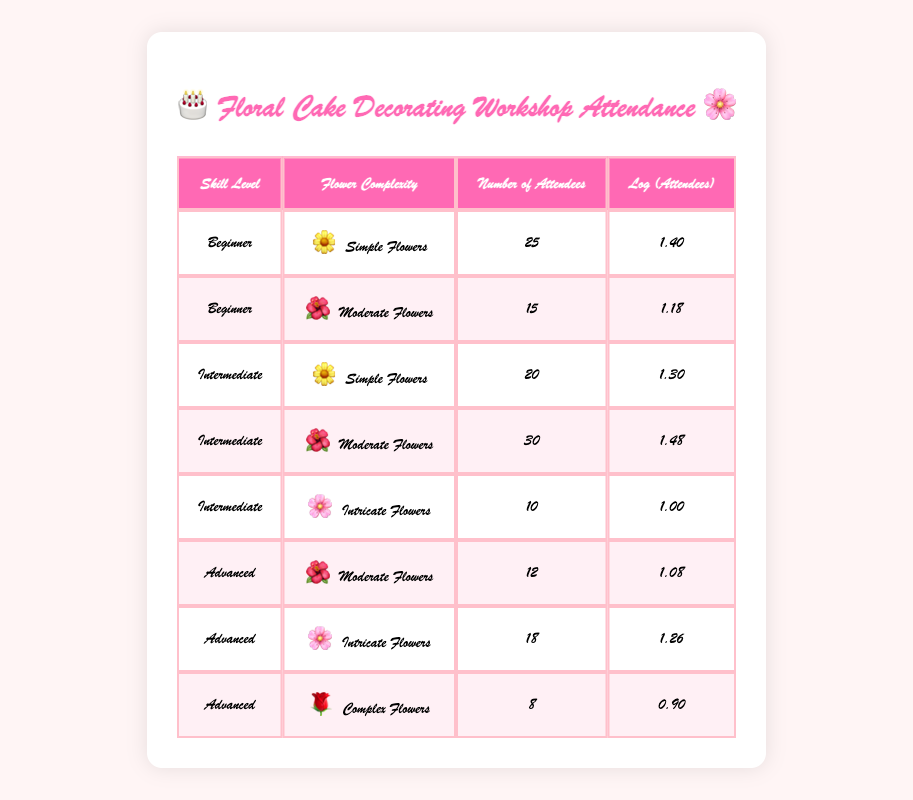What is the number of attendees for Intermediate skill level and Moderate Flowers? From the table, under the Intermediate skill level, the row for Moderate Flowers shows a number of attendees as 30.
Answer: 30 What is the logarithmic value for the number of attendees in Advanced skill level and Complex Flowers? In the table, the Advanced skill level for Complex Flowers has 8 attendees, and the logarithmic value for this is listed as 0.90.
Answer: 0.90 How many total attendees participated in Simple Flowers across all skill levels? To find the total for Simple Flowers, we look at the rows for each skill level: 25 (Beginner) + 20 (Intermediate) = 45. Therefore, the total attendees for Simple Flowers is 45.
Answer: 45 What is the average number of attendees for Advanced skill level sessions? For Advanced skill level: the number of attendees are 12 (Moderate) + 18 (Intricate) + 8 (Complex) = 38. There are 3 sessions, so the average is 38 / 3 = 12.67.
Answer: 12.67 Is the number of attendees for Beginner skill level and Moderate Flowers higher than for Intermediate skill level and Simple Flowers? The Beginner skill level for Moderate Flowers has 15 attendees, while Intermediate skill level for Simple Flowers has 20 attendees. Thus, 15 is not higher than 20, making the statement false.
Answer: No Which flower complexity category has the highest number of attendees for the Intermediate skill level? Within the Intermediate skill level, the number of attendees for each flower complexity is: 20 (Simple Flowers), 30 (Moderate Flowers), and 10 (Intricate Flowers). The highest is 30 attendees for Moderate Flowers.
Answer: Moderate Flowers What is the total number of attendees in the workshops that involve Intricate Flowers? For Intricate Flowers, we have: 10 attendees (Intermediate) + 18 attendees (Advanced) = 28 attendees in total across the listed workshops.
Answer: 28 Which skill level had the lowest logarithmic value for attendees? Looking at the logarithmic values: 1.40 (Beginner, Simple), 1.18 (Beginner, Moderate), 1.30 (Intermediate, Simple), 1.48 (Intermediate, Moderate), 1.00 (Intermediate, Intricate), 1.08 (Advanced, Moderate), 1.26 (Advanced, Intricate), and 0.90 (Advanced, Complex). The lowest value is 0.90 for Advanced, Complex Flowers.
Answer: Advanced, Complex Flowers 